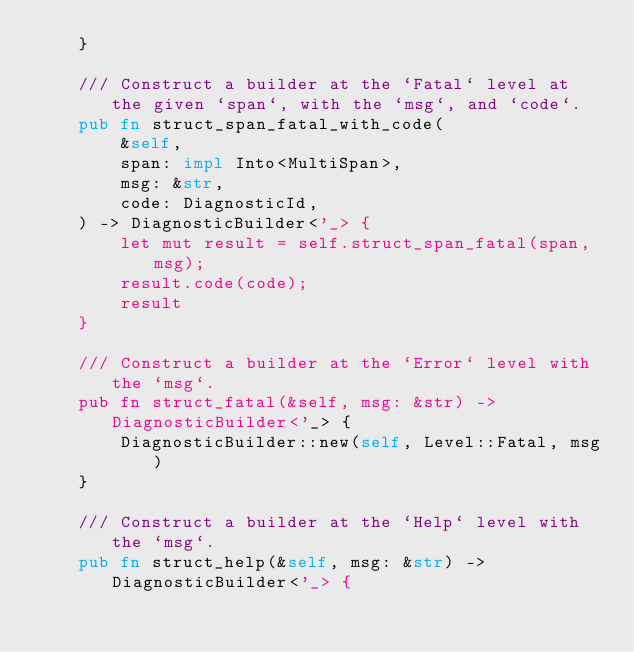Convert code to text. <code><loc_0><loc_0><loc_500><loc_500><_Rust_>    }

    /// Construct a builder at the `Fatal` level at the given `span`, with the `msg`, and `code`.
    pub fn struct_span_fatal_with_code(
        &self,
        span: impl Into<MultiSpan>,
        msg: &str,
        code: DiagnosticId,
    ) -> DiagnosticBuilder<'_> {
        let mut result = self.struct_span_fatal(span, msg);
        result.code(code);
        result
    }

    /// Construct a builder at the `Error` level with the `msg`.
    pub fn struct_fatal(&self, msg: &str) -> DiagnosticBuilder<'_> {
        DiagnosticBuilder::new(self, Level::Fatal, msg)
    }

    /// Construct a builder at the `Help` level with the `msg`.
    pub fn struct_help(&self, msg: &str) -> DiagnosticBuilder<'_> {</code> 